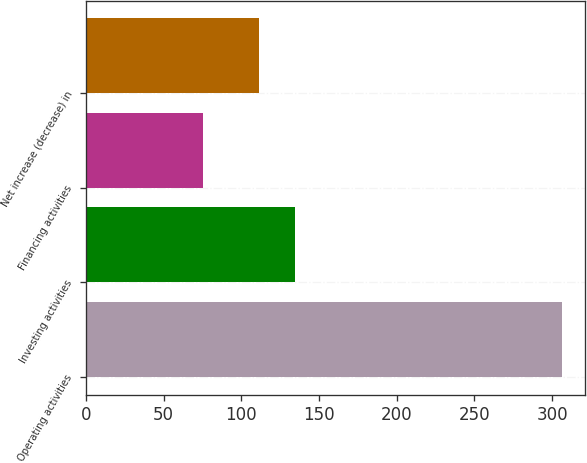Convert chart to OTSL. <chart><loc_0><loc_0><loc_500><loc_500><bar_chart><fcel>Operating activities<fcel>Investing activities<fcel>Financing activities<fcel>Net increase (decrease) in<nl><fcel>306.1<fcel>134.36<fcel>75.5<fcel>111.3<nl></chart> 